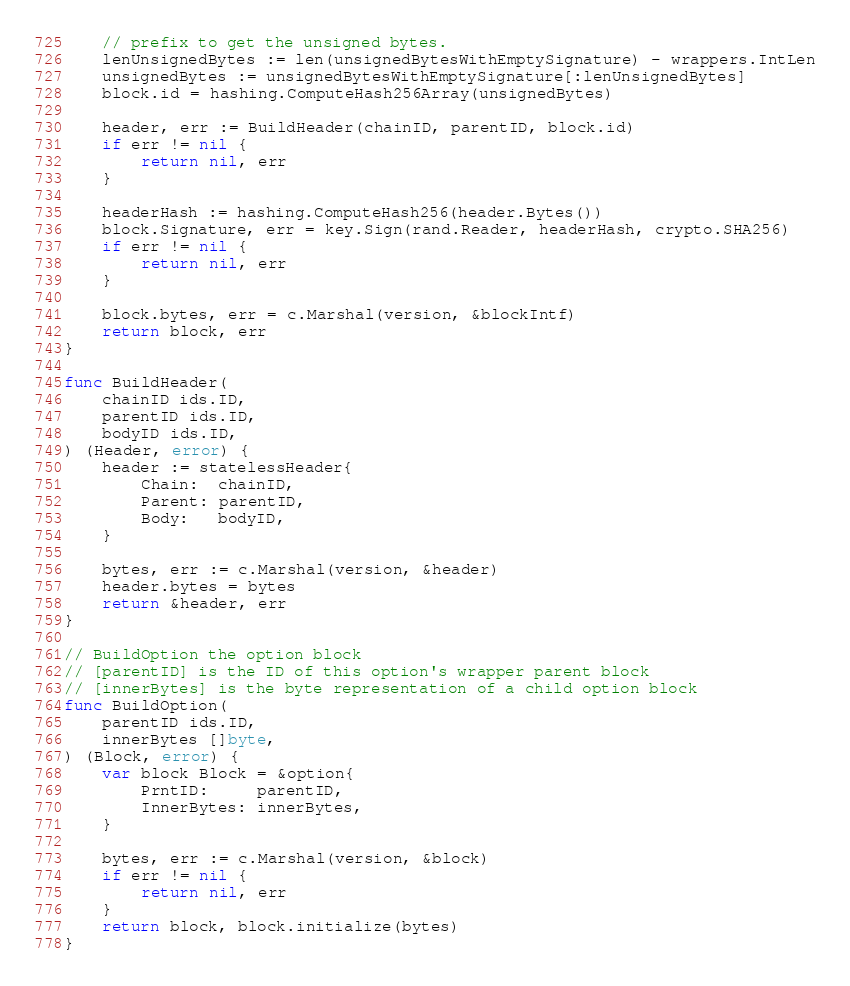<code> <loc_0><loc_0><loc_500><loc_500><_Go_>	// prefix to get the unsigned bytes.
	lenUnsignedBytes := len(unsignedBytesWithEmptySignature) - wrappers.IntLen
	unsignedBytes := unsignedBytesWithEmptySignature[:lenUnsignedBytes]
	block.id = hashing.ComputeHash256Array(unsignedBytes)

	header, err := BuildHeader(chainID, parentID, block.id)
	if err != nil {
		return nil, err
	}

	headerHash := hashing.ComputeHash256(header.Bytes())
	block.Signature, err = key.Sign(rand.Reader, headerHash, crypto.SHA256)
	if err != nil {
		return nil, err
	}

	block.bytes, err = c.Marshal(version, &blockIntf)
	return block, err
}

func BuildHeader(
	chainID ids.ID,
	parentID ids.ID,
	bodyID ids.ID,
) (Header, error) {
	header := statelessHeader{
		Chain:  chainID,
		Parent: parentID,
		Body:   bodyID,
	}

	bytes, err := c.Marshal(version, &header)
	header.bytes = bytes
	return &header, err
}

// BuildOption the option block
// [parentID] is the ID of this option's wrapper parent block
// [innerBytes] is the byte representation of a child option block
func BuildOption(
	parentID ids.ID,
	innerBytes []byte,
) (Block, error) {
	var block Block = &option{
		PrntID:     parentID,
		InnerBytes: innerBytes,
	}

	bytes, err := c.Marshal(version, &block)
	if err != nil {
		return nil, err
	}
	return block, block.initialize(bytes)
}
</code> 